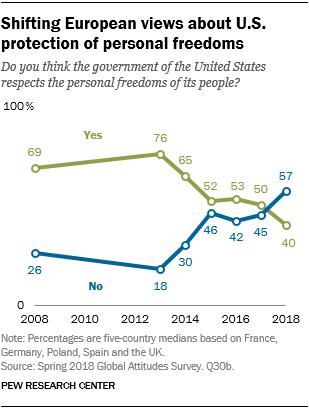Point out several critical features in this image. The color of the "Yes" graph is green, and it is also a yes. In 2008, the difference between blue and green was not the maximum among years. 